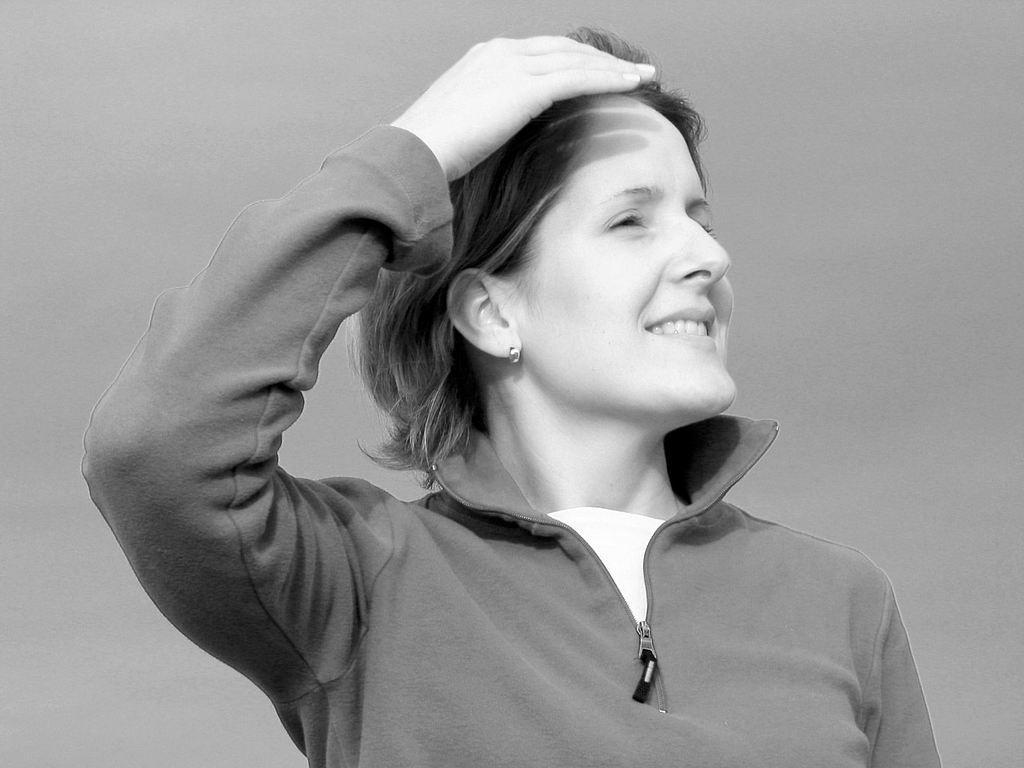Can you describe this image briefly? This looks like a black and white image. I can see the woman standing and smiling. She wore a jerkin. 